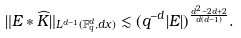<formula> <loc_0><loc_0><loc_500><loc_500>\| E \ast \widehat { K } \| _ { L ^ { d - 1 } ( { \mathbb { F } _ { q } ^ { d } } , d x ) } \lesssim ( q ^ { - d } | E | ) ^ { \frac { d ^ { 2 } - 2 d + 2 } { d ( d - 1 ) } } .</formula> 